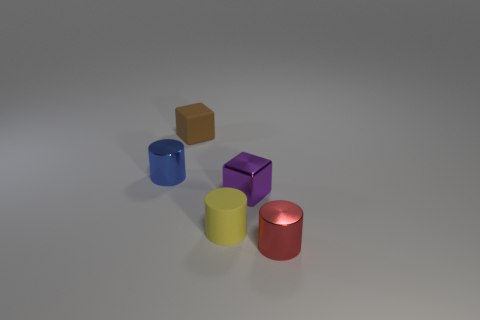Add 5 small cyan cylinders. How many objects exist? 10 Subtract all cubes. How many objects are left? 3 Add 2 tiny purple metal balls. How many tiny purple metal balls exist? 2 Subtract 1 yellow cylinders. How many objects are left? 4 Subtract all shiny things. Subtract all small brown rubber blocks. How many objects are left? 1 Add 4 blue metallic objects. How many blue metallic objects are left? 5 